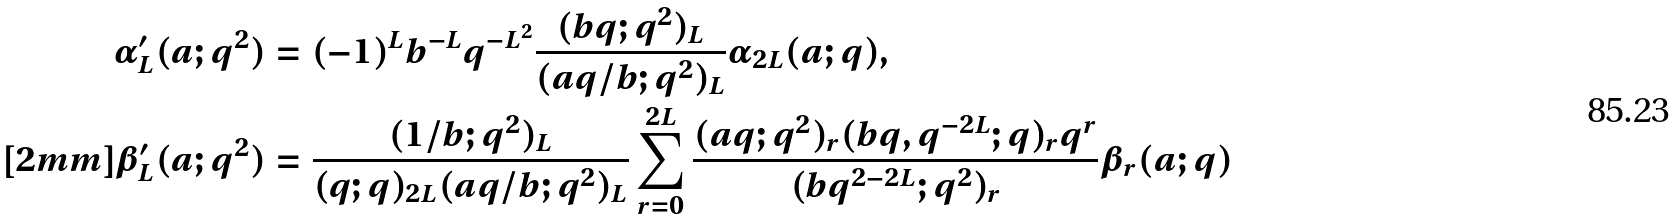Convert formula to latex. <formula><loc_0><loc_0><loc_500><loc_500>\alpha ^ { \prime } _ { L } ( a ; q ^ { 2 } ) & = ( - 1 ) ^ { L } b ^ { - L } q ^ { - L ^ { 2 } } \frac { ( b q ; q ^ { 2 } ) _ { L } } { ( a q / b ; q ^ { 2 } ) _ { L } } \alpha _ { 2 L } ( a ; q ) , \\ [ 2 m m ] \beta ^ { \prime } _ { L } ( a ; q ^ { 2 } ) & = \frac { ( 1 / b ; q ^ { 2 } ) _ { L } } { ( q ; q ) _ { 2 L } ( a q / b ; q ^ { 2 } ) _ { L } } \sum _ { r = 0 } ^ { 2 L } \frac { ( a q ; q ^ { 2 } ) _ { r } ( b q , q ^ { - 2 L } ; q ) _ { r } q ^ { r } } { ( b q ^ { 2 - 2 L } ; q ^ { 2 } ) _ { r } } \beta _ { r } ( a ; q )</formula> 